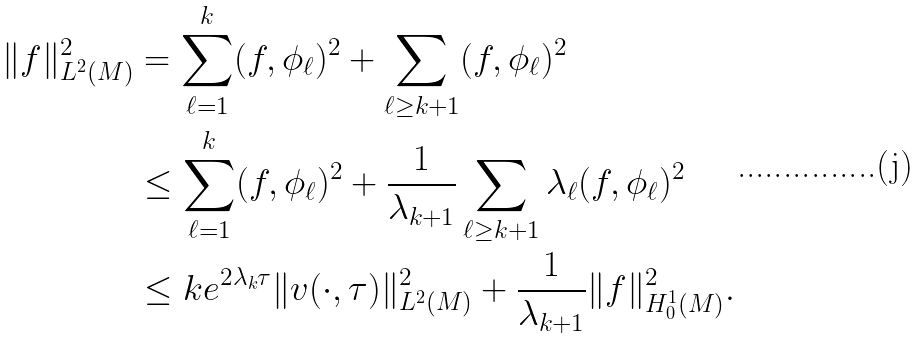<formula> <loc_0><loc_0><loc_500><loc_500>\| f \| _ { L ^ { 2 } ( M ) } ^ { 2 } & = \sum _ { \ell = 1 } ^ { k } ( f , \phi _ { \ell } ) ^ { 2 } + \sum _ { \ell \geq k + 1 } ( f , \phi _ { \ell } ) ^ { 2 } \\ & \leq \sum _ { \ell = 1 } ^ { k } ( f , \phi _ { \ell } ) ^ { 2 } + \frac { 1 } { \lambda _ { k + 1 } } \sum _ { \ell \geq k + 1 } \lambda _ { \ell } ( f , \phi _ { \ell } ) ^ { 2 } \\ & \leq k e ^ { 2 \lambda _ { k } \tau } \| v ( \cdot , \tau ) \| _ { L ^ { 2 } ( M ) } ^ { 2 } + \frac { 1 } { \lambda _ { k + 1 } } \| f \| _ { H _ { 0 } ^ { 1 } ( M ) } ^ { 2 } .</formula> 